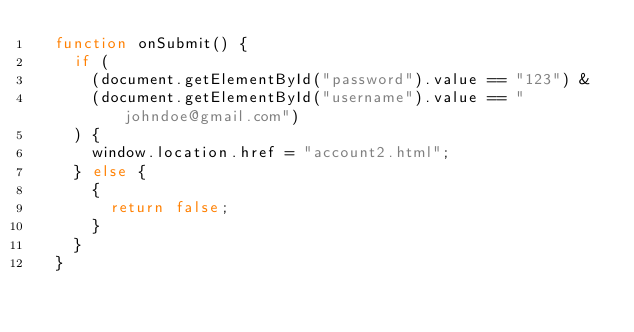<code> <loc_0><loc_0><loc_500><loc_500><_JavaScript_>  function onSubmit() {
    if (
      (document.getElementById("password").value == "123") &
      (document.getElementById("username").value == "johndoe@gmail.com")
    ) {
      window.location.href = "account2.html";
    } else {
      {
        return false;
      }
    }
  }</code> 